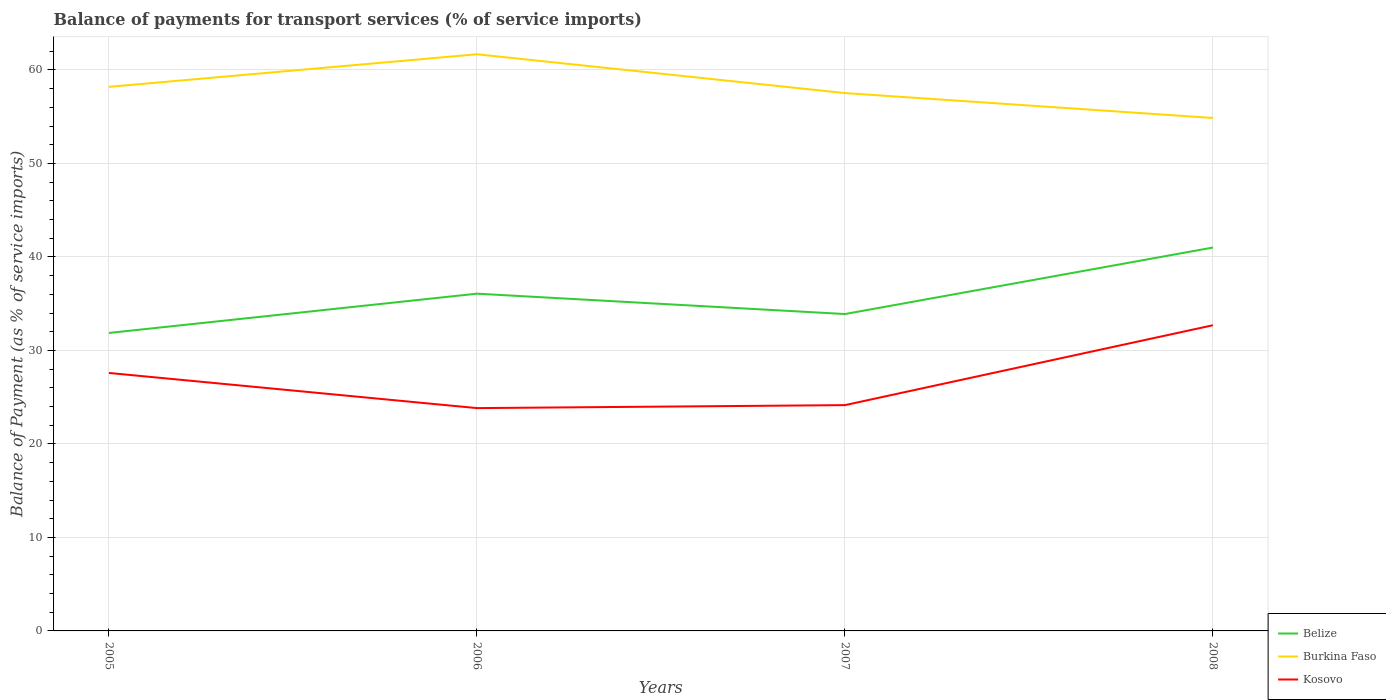How many different coloured lines are there?
Your answer should be compact. 3. Is the number of lines equal to the number of legend labels?
Give a very brief answer. Yes. Across all years, what is the maximum balance of payments for transport services in Belize?
Make the answer very short. 31.87. In which year was the balance of payments for transport services in Burkina Faso maximum?
Ensure brevity in your answer.  2008. What is the total balance of payments for transport services in Kosovo in the graph?
Ensure brevity in your answer.  -8.54. What is the difference between the highest and the second highest balance of payments for transport services in Kosovo?
Make the answer very short. 8.86. What is the difference between the highest and the lowest balance of payments for transport services in Belize?
Offer a terse response. 2. How many lines are there?
Provide a short and direct response. 3. Are the values on the major ticks of Y-axis written in scientific E-notation?
Your answer should be compact. No. Does the graph contain any zero values?
Make the answer very short. No. What is the title of the graph?
Offer a terse response. Balance of payments for transport services (% of service imports). What is the label or title of the Y-axis?
Your answer should be very brief. Balance of Payment (as % of service imports). What is the Balance of Payment (as % of service imports) of Belize in 2005?
Provide a short and direct response. 31.87. What is the Balance of Payment (as % of service imports) of Burkina Faso in 2005?
Provide a short and direct response. 58.19. What is the Balance of Payment (as % of service imports) of Kosovo in 2005?
Make the answer very short. 27.59. What is the Balance of Payment (as % of service imports) of Belize in 2006?
Provide a succinct answer. 36.07. What is the Balance of Payment (as % of service imports) in Burkina Faso in 2006?
Offer a terse response. 61.68. What is the Balance of Payment (as % of service imports) in Kosovo in 2006?
Ensure brevity in your answer.  23.83. What is the Balance of Payment (as % of service imports) of Belize in 2007?
Keep it short and to the point. 33.89. What is the Balance of Payment (as % of service imports) of Burkina Faso in 2007?
Offer a very short reply. 57.53. What is the Balance of Payment (as % of service imports) of Kosovo in 2007?
Your answer should be compact. 24.15. What is the Balance of Payment (as % of service imports) in Belize in 2008?
Provide a succinct answer. 41.01. What is the Balance of Payment (as % of service imports) in Burkina Faso in 2008?
Give a very brief answer. 54.87. What is the Balance of Payment (as % of service imports) in Kosovo in 2008?
Make the answer very short. 32.7. Across all years, what is the maximum Balance of Payment (as % of service imports) in Belize?
Your answer should be compact. 41.01. Across all years, what is the maximum Balance of Payment (as % of service imports) in Burkina Faso?
Provide a succinct answer. 61.68. Across all years, what is the maximum Balance of Payment (as % of service imports) in Kosovo?
Your response must be concise. 32.7. Across all years, what is the minimum Balance of Payment (as % of service imports) of Belize?
Provide a short and direct response. 31.87. Across all years, what is the minimum Balance of Payment (as % of service imports) in Burkina Faso?
Your response must be concise. 54.87. Across all years, what is the minimum Balance of Payment (as % of service imports) in Kosovo?
Give a very brief answer. 23.83. What is the total Balance of Payment (as % of service imports) of Belize in the graph?
Give a very brief answer. 142.85. What is the total Balance of Payment (as % of service imports) in Burkina Faso in the graph?
Your response must be concise. 232.27. What is the total Balance of Payment (as % of service imports) of Kosovo in the graph?
Provide a succinct answer. 108.27. What is the difference between the Balance of Payment (as % of service imports) of Belize in 2005 and that in 2006?
Keep it short and to the point. -4.2. What is the difference between the Balance of Payment (as % of service imports) in Burkina Faso in 2005 and that in 2006?
Offer a terse response. -3.49. What is the difference between the Balance of Payment (as % of service imports) in Kosovo in 2005 and that in 2006?
Your answer should be compact. 3.76. What is the difference between the Balance of Payment (as % of service imports) in Belize in 2005 and that in 2007?
Offer a very short reply. -2.02. What is the difference between the Balance of Payment (as % of service imports) of Burkina Faso in 2005 and that in 2007?
Offer a terse response. 0.66. What is the difference between the Balance of Payment (as % of service imports) of Kosovo in 2005 and that in 2007?
Offer a very short reply. 3.44. What is the difference between the Balance of Payment (as % of service imports) of Belize in 2005 and that in 2008?
Your answer should be very brief. -9.14. What is the difference between the Balance of Payment (as % of service imports) in Burkina Faso in 2005 and that in 2008?
Provide a short and direct response. 3.33. What is the difference between the Balance of Payment (as % of service imports) of Kosovo in 2005 and that in 2008?
Give a very brief answer. -5.1. What is the difference between the Balance of Payment (as % of service imports) of Belize in 2006 and that in 2007?
Make the answer very short. 2.18. What is the difference between the Balance of Payment (as % of service imports) of Burkina Faso in 2006 and that in 2007?
Offer a very short reply. 4.15. What is the difference between the Balance of Payment (as % of service imports) in Kosovo in 2006 and that in 2007?
Provide a succinct answer. -0.32. What is the difference between the Balance of Payment (as % of service imports) of Belize in 2006 and that in 2008?
Your response must be concise. -4.93. What is the difference between the Balance of Payment (as % of service imports) of Burkina Faso in 2006 and that in 2008?
Your answer should be very brief. 6.81. What is the difference between the Balance of Payment (as % of service imports) of Kosovo in 2006 and that in 2008?
Your answer should be very brief. -8.86. What is the difference between the Balance of Payment (as % of service imports) of Belize in 2007 and that in 2008?
Offer a terse response. -7.11. What is the difference between the Balance of Payment (as % of service imports) in Burkina Faso in 2007 and that in 2008?
Offer a terse response. 2.66. What is the difference between the Balance of Payment (as % of service imports) of Kosovo in 2007 and that in 2008?
Give a very brief answer. -8.54. What is the difference between the Balance of Payment (as % of service imports) of Belize in 2005 and the Balance of Payment (as % of service imports) of Burkina Faso in 2006?
Keep it short and to the point. -29.81. What is the difference between the Balance of Payment (as % of service imports) in Belize in 2005 and the Balance of Payment (as % of service imports) in Kosovo in 2006?
Provide a short and direct response. 8.04. What is the difference between the Balance of Payment (as % of service imports) of Burkina Faso in 2005 and the Balance of Payment (as % of service imports) of Kosovo in 2006?
Offer a very short reply. 34.36. What is the difference between the Balance of Payment (as % of service imports) in Belize in 2005 and the Balance of Payment (as % of service imports) in Burkina Faso in 2007?
Offer a terse response. -25.66. What is the difference between the Balance of Payment (as % of service imports) of Belize in 2005 and the Balance of Payment (as % of service imports) of Kosovo in 2007?
Keep it short and to the point. 7.72. What is the difference between the Balance of Payment (as % of service imports) in Burkina Faso in 2005 and the Balance of Payment (as % of service imports) in Kosovo in 2007?
Make the answer very short. 34.04. What is the difference between the Balance of Payment (as % of service imports) of Belize in 2005 and the Balance of Payment (as % of service imports) of Burkina Faso in 2008?
Your answer should be very brief. -23. What is the difference between the Balance of Payment (as % of service imports) of Belize in 2005 and the Balance of Payment (as % of service imports) of Kosovo in 2008?
Your answer should be compact. -0.83. What is the difference between the Balance of Payment (as % of service imports) of Burkina Faso in 2005 and the Balance of Payment (as % of service imports) of Kosovo in 2008?
Offer a terse response. 25.5. What is the difference between the Balance of Payment (as % of service imports) of Belize in 2006 and the Balance of Payment (as % of service imports) of Burkina Faso in 2007?
Offer a terse response. -21.46. What is the difference between the Balance of Payment (as % of service imports) of Belize in 2006 and the Balance of Payment (as % of service imports) of Kosovo in 2007?
Give a very brief answer. 11.92. What is the difference between the Balance of Payment (as % of service imports) in Burkina Faso in 2006 and the Balance of Payment (as % of service imports) in Kosovo in 2007?
Your response must be concise. 37.53. What is the difference between the Balance of Payment (as % of service imports) in Belize in 2006 and the Balance of Payment (as % of service imports) in Burkina Faso in 2008?
Make the answer very short. -18.79. What is the difference between the Balance of Payment (as % of service imports) of Belize in 2006 and the Balance of Payment (as % of service imports) of Kosovo in 2008?
Your answer should be compact. 3.38. What is the difference between the Balance of Payment (as % of service imports) in Burkina Faso in 2006 and the Balance of Payment (as % of service imports) in Kosovo in 2008?
Your answer should be very brief. 28.98. What is the difference between the Balance of Payment (as % of service imports) in Belize in 2007 and the Balance of Payment (as % of service imports) in Burkina Faso in 2008?
Offer a terse response. -20.97. What is the difference between the Balance of Payment (as % of service imports) of Belize in 2007 and the Balance of Payment (as % of service imports) of Kosovo in 2008?
Offer a terse response. 1.2. What is the difference between the Balance of Payment (as % of service imports) in Burkina Faso in 2007 and the Balance of Payment (as % of service imports) in Kosovo in 2008?
Ensure brevity in your answer.  24.83. What is the average Balance of Payment (as % of service imports) of Belize per year?
Offer a very short reply. 35.71. What is the average Balance of Payment (as % of service imports) of Burkina Faso per year?
Make the answer very short. 58.07. What is the average Balance of Payment (as % of service imports) of Kosovo per year?
Provide a short and direct response. 27.07. In the year 2005, what is the difference between the Balance of Payment (as % of service imports) of Belize and Balance of Payment (as % of service imports) of Burkina Faso?
Give a very brief answer. -26.32. In the year 2005, what is the difference between the Balance of Payment (as % of service imports) in Belize and Balance of Payment (as % of service imports) in Kosovo?
Your response must be concise. 4.28. In the year 2005, what is the difference between the Balance of Payment (as % of service imports) of Burkina Faso and Balance of Payment (as % of service imports) of Kosovo?
Offer a terse response. 30.6. In the year 2006, what is the difference between the Balance of Payment (as % of service imports) in Belize and Balance of Payment (as % of service imports) in Burkina Faso?
Provide a short and direct response. -25.61. In the year 2006, what is the difference between the Balance of Payment (as % of service imports) of Belize and Balance of Payment (as % of service imports) of Kosovo?
Your answer should be very brief. 12.24. In the year 2006, what is the difference between the Balance of Payment (as % of service imports) in Burkina Faso and Balance of Payment (as % of service imports) in Kosovo?
Offer a terse response. 37.85. In the year 2007, what is the difference between the Balance of Payment (as % of service imports) in Belize and Balance of Payment (as % of service imports) in Burkina Faso?
Your response must be concise. -23.64. In the year 2007, what is the difference between the Balance of Payment (as % of service imports) of Belize and Balance of Payment (as % of service imports) of Kosovo?
Offer a terse response. 9.74. In the year 2007, what is the difference between the Balance of Payment (as % of service imports) in Burkina Faso and Balance of Payment (as % of service imports) in Kosovo?
Offer a terse response. 33.38. In the year 2008, what is the difference between the Balance of Payment (as % of service imports) in Belize and Balance of Payment (as % of service imports) in Burkina Faso?
Provide a succinct answer. -13.86. In the year 2008, what is the difference between the Balance of Payment (as % of service imports) of Belize and Balance of Payment (as % of service imports) of Kosovo?
Ensure brevity in your answer.  8.31. In the year 2008, what is the difference between the Balance of Payment (as % of service imports) of Burkina Faso and Balance of Payment (as % of service imports) of Kosovo?
Keep it short and to the point. 22.17. What is the ratio of the Balance of Payment (as % of service imports) in Belize in 2005 to that in 2006?
Provide a short and direct response. 0.88. What is the ratio of the Balance of Payment (as % of service imports) in Burkina Faso in 2005 to that in 2006?
Give a very brief answer. 0.94. What is the ratio of the Balance of Payment (as % of service imports) in Kosovo in 2005 to that in 2006?
Provide a succinct answer. 1.16. What is the ratio of the Balance of Payment (as % of service imports) in Belize in 2005 to that in 2007?
Your answer should be very brief. 0.94. What is the ratio of the Balance of Payment (as % of service imports) of Burkina Faso in 2005 to that in 2007?
Keep it short and to the point. 1.01. What is the ratio of the Balance of Payment (as % of service imports) in Kosovo in 2005 to that in 2007?
Your answer should be compact. 1.14. What is the ratio of the Balance of Payment (as % of service imports) in Belize in 2005 to that in 2008?
Make the answer very short. 0.78. What is the ratio of the Balance of Payment (as % of service imports) in Burkina Faso in 2005 to that in 2008?
Keep it short and to the point. 1.06. What is the ratio of the Balance of Payment (as % of service imports) in Kosovo in 2005 to that in 2008?
Keep it short and to the point. 0.84. What is the ratio of the Balance of Payment (as % of service imports) in Belize in 2006 to that in 2007?
Give a very brief answer. 1.06. What is the ratio of the Balance of Payment (as % of service imports) in Burkina Faso in 2006 to that in 2007?
Keep it short and to the point. 1.07. What is the ratio of the Balance of Payment (as % of service imports) in Kosovo in 2006 to that in 2007?
Offer a terse response. 0.99. What is the ratio of the Balance of Payment (as % of service imports) of Belize in 2006 to that in 2008?
Provide a short and direct response. 0.88. What is the ratio of the Balance of Payment (as % of service imports) of Burkina Faso in 2006 to that in 2008?
Keep it short and to the point. 1.12. What is the ratio of the Balance of Payment (as % of service imports) of Kosovo in 2006 to that in 2008?
Your answer should be very brief. 0.73. What is the ratio of the Balance of Payment (as % of service imports) in Belize in 2007 to that in 2008?
Provide a succinct answer. 0.83. What is the ratio of the Balance of Payment (as % of service imports) of Burkina Faso in 2007 to that in 2008?
Provide a short and direct response. 1.05. What is the ratio of the Balance of Payment (as % of service imports) of Kosovo in 2007 to that in 2008?
Your response must be concise. 0.74. What is the difference between the highest and the second highest Balance of Payment (as % of service imports) of Belize?
Keep it short and to the point. 4.93. What is the difference between the highest and the second highest Balance of Payment (as % of service imports) of Burkina Faso?
Provide a succinct answer. 3.49. What is the difference between the highest and the second highest Balance of Payment (as % of service imports) in Kosovo?
Ensure brevity in your answer.  5.1. What is the difference between the highest and the lowest Balance of Payment (as % of service imports) in Belize?
Your answer should be compact. 9.14. What is the difference between the highest and the lowest Balance of Payment (as % of service imports) of Burkina Faso?
Your answer should be very brief. 6.81. What is the difference between the highest and the lowest Balance of Payment (as % of service imports) in Kosovo?
Offer a very short reply. 8.86. 